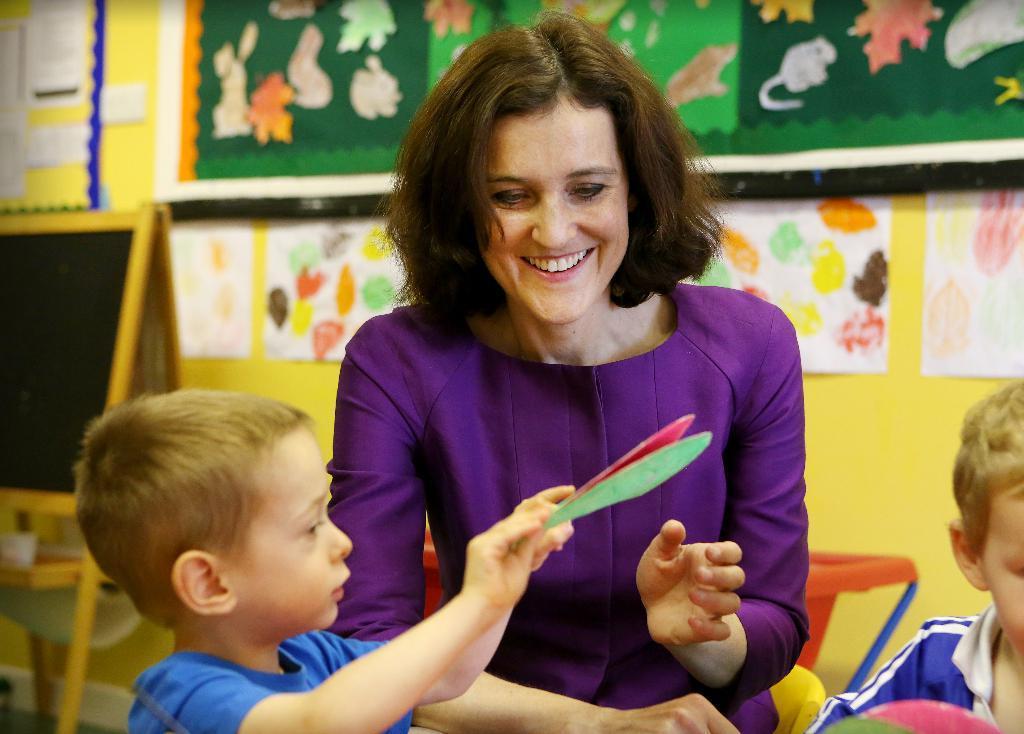Describe this image in one or two sentences. In this image I can see a woman is smiling, she wore a brinjal color dress. On the left side there is a boy in blue color t-shirt, at the back side there are papers stick to the wall 